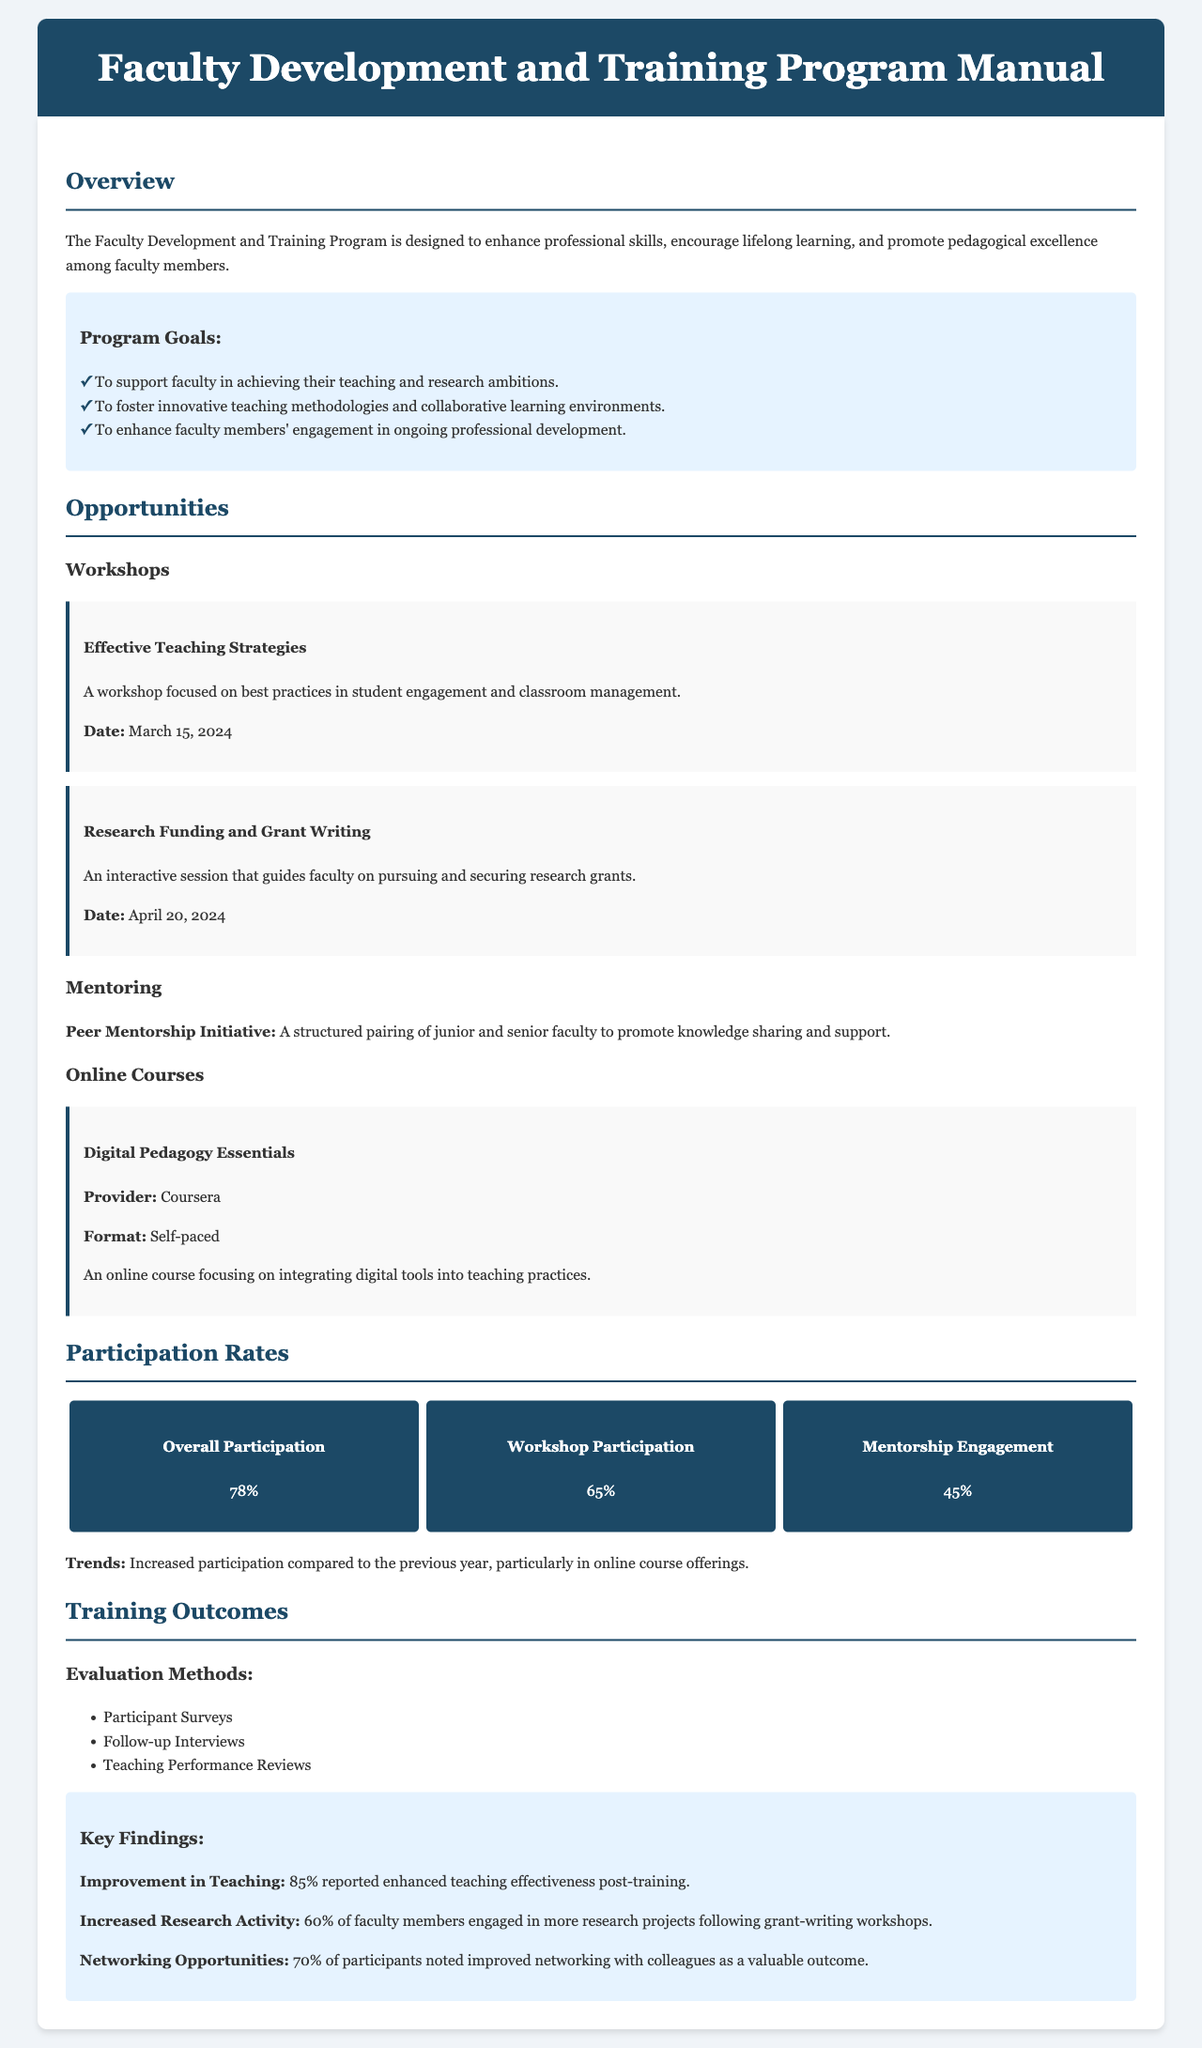What is the overall participation rate? The overall participation rate is presented in the statistics section of the document.
Answer: 78% When is the "Effective Teaching Strategies" workshop scheduled? The date for the "Effective Teaching Strategies" workshop is specified under the Workshops section.
Answer: March 15, 2024 What percentage of participants noted improved networking? This percentage is provided in the key findings of the training outcomes section.
Answer: 70% What is one of the evaluation methods used for training outcomes? The evaluation methods are listed in the training outcomes section.
Answer: Participant Surveys What is the primary goal of the Faculty Development and Training Program? The main purpose is highlighted in the overview section.
Answer: Enhance professional skills What type of online course is mentioned in the manual? The type of online course is specified in the opportunities section.
Answer: Digital Pedagogy Essentials What percentage of faculty members engaged in more research projects after training? This percentage is included in the key findings under training outcomes.
Answer: 60% What initiative promotes knowledge sharing among faculty? This initiative is described in the opportunities section of the document.
Answer: Peer Mentorship Initiative 